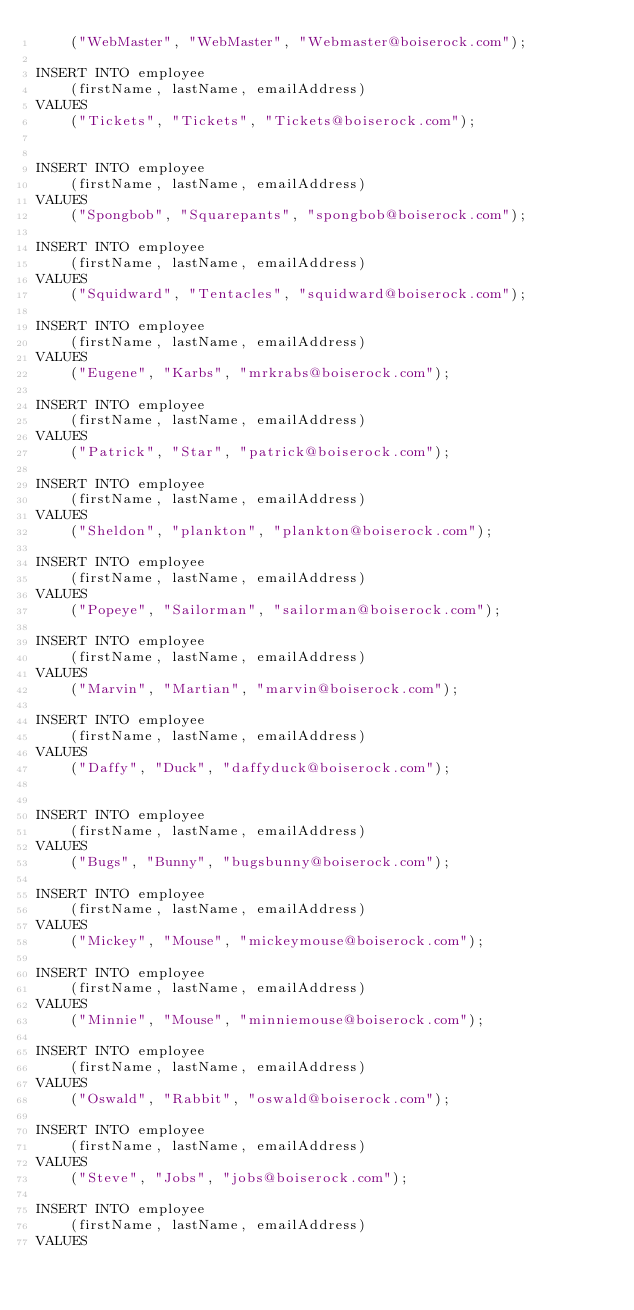<code> <loc_0><loc_0><loc_500><loc_500><_SQL_>	("WebMaster", "WebMaster", "Webmaster@boiserock.com");
	
INSERT INTO employee 
	(firstName, lastName, emailAddress)
VALUES
	("Tickets", "Tickets", "Tickets@boiserock.com");
	

INSERT INTO employee 
	(firstName, lastName, emailAddress)
VALUES
	("Spongbob", "Squarepants", "spongbob@boiserock.com");
	
INSERT INTO employee 
	(firstName, lastName, emailAddress)
VALUES
	("Squidward", "Tentacles", "squidward@boiserock.com");

INSERT INTO employee 
	(firstName, lastName, emailAddress)
VALUES
	("Eugene", "Karbs", "mrkrabs@boiserock.com");
	
INSERT INTO employee 
	(firstName, lastName, emailAddress)
VALUES
	("Patrick", "Star", "patrick@boiserock.com");
	
INSERT INTO employee 
	(firstName, lastName, emailAddress)
VALUES
	("Sheldon", "plankton", "plankton@boiserock.com");
	
INSERT INTO employee 
	(firstName, lastName, emailAddress)
VALUES
	("Popeye", "Sailorman", "sailorman@boiserock.com");
	
INSERT INTO employee 
	(firstName, lastName, emailAddress)
VALUES
	("Marvin", "Martian", "marvin@boiserock.com");

INSERT INTO employee 
	(firstName, lastName, emailAddress)
VALUES
	("Daffy", "Duck", "daffyduck@boiserock.com");
	
	
INSERT INTO employee 
	(firstName, lastName, emailAddress)
VALUES
	("Bugs", "Bunny", "bugsbunny@boiserock.com");

INSERT INTO employee 
	(firstName, lastName, emailAddress)
VALUES
	("Mickey", "Mouse", "mickeymouse@boiserock.com");	

INSERT INTO employee 
	(firstName, lastName, emailAddress)
VALUES
	("Minnie", "Mouse", "minniemouse@boiserock.com");	
	
INSERT INTO employee 
	(firstName, lastName, emailAddress)
VALUES
	("Oswald", "Rabbit", "oswald@boiserock.com");	
	
INSERT INTO employee 
	(firstName, lastName, emailAddress)
VALUES
	("Steve", "Jobs", "jobs@boiserock.com");	
	
INSERT INTO employee 
	(firstName, lastName, emailAddress)
VALUES</code> 